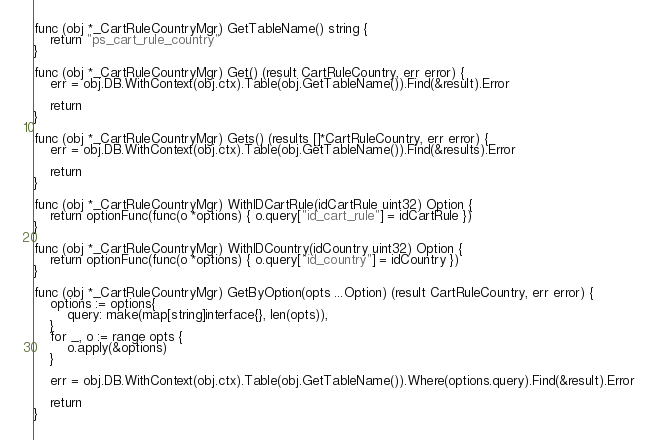Convert code to text. <code><loc_0><loc_0><loc_500><loc_500><_Go_>
func (obj *_CartRuleCountryMgr) GetTableName() string {
	return "ps_cart_rule_country"
}

func (obj *_CartRuleCountryMgr) Get() (result CartRuleCountry, err error) {
	err = obj.DB.WithContext(obj.ctx).Table(obj.GetTableName()).Find(&result).Error

	return
}

func (obj *_CartRuleCountryMgr) Gets() (results []*CartRuleCountry, err error) {
	err = obj.DB.WithContext(obj.ctx).Table(obj.GetTableName()).Find(&results).Error

	return
}

func (obj *_CartRuleCountryMgr) WithIDCartRule(idCartRule uint32) Option {
	return optionFunc(func(o *options) { o.query["id_cart_rule"] = idCartRule })
}

func (obj *_CartRuleCountryMgr) WithIDCountry(idCountry uint32) Option {
	return optionFunc(func(o *options) { o.query["id_country"] = idCountry })
}

func (obj *_CartRuleCountryMgr) GetByOption(opts ...Option) (result CartRuleCountry, err error) {
	options := options{
		query: make(map[string]interface{}, len(opts)),
	}
	for _, o := range opts {
		o.apply(&options)
	}

	err = obj.DB.WithContext(obj.ctx).Table(obj.GetTableName()).Where(options.query).Find(&result).Error

	return
}
</code> 